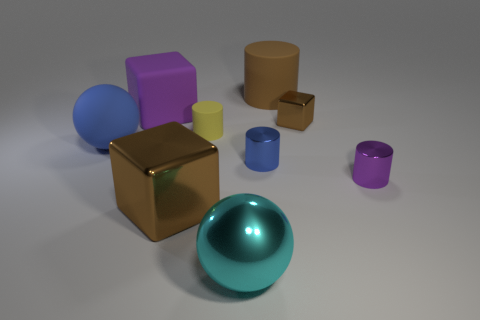Add 1 small objects. How many objects exist? 10 Subtract all cylinders. How many objects are left? 5 Subtract 0 red cubes. How many objects are left? 9 Subtract all small brown cubes. Subtract all large cubes. How many objects are left? 6 Add 8 spheres. How many spheres are left? 10 Add 5 gray rubber blocks. How many gray rubber blocks exist? 5 